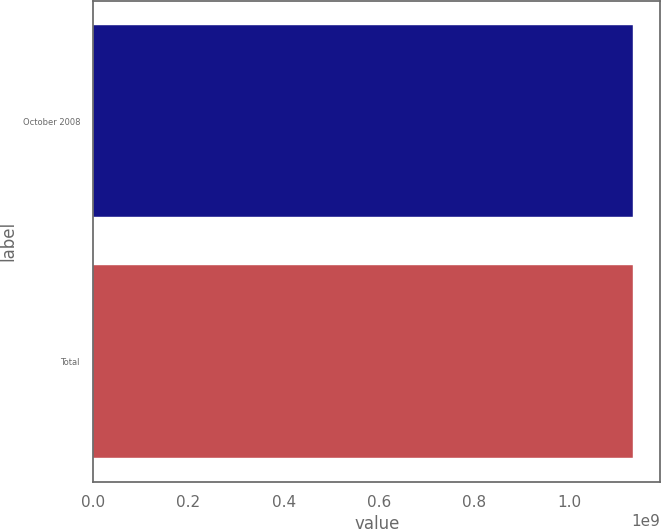<chart> <loc_0><loc_0><loc_500><loc_500><bar_chart><fcel>October 2008<fcel>Total<nl><fcel>1.13435e+09<fcel>1.13435e+09<nl></chart> 